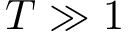Convert formula to latex. <formula><loc_0><loc_0><loc_500><loc_500>T \gg 1</formula> 